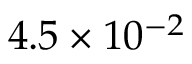<formula> <loc_0><loc_0><loc_500><loc_500>4 . 5 \times 1 0 ^ { - 2 }</formula> 